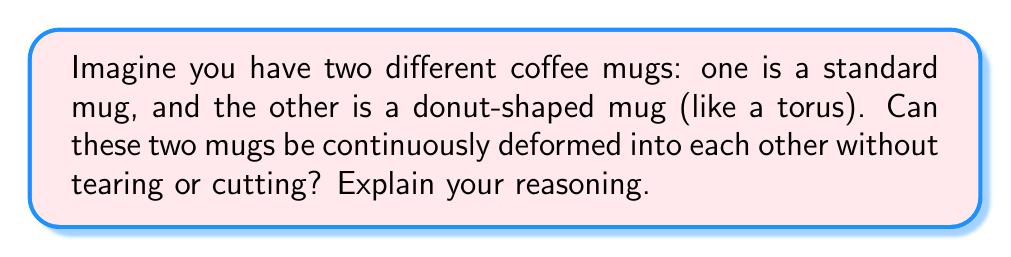Give your solution to this math problem. To answer this question, we need to understand the concept of topological equivalence. Two shapes are topologically equivalent if they can be continuously deformed into each other without tearing, cutting, or gluing.

Let's analyze the two shapes:

1. Standard mug: A standard mug is topologically equivalent to a solid cylinder. It has one hole (the handle).

2. Donut-shaped mug (torus): This mug is shaped like a donut, with one large hole through the center and another hole for the handle.

To determine if these shapes are topologically equivalent, we need to count the number of holes in each shape:

- Standard mug: 1 hole (the handle)
- Donut-shaped mug: 2 holes (the center hole and the handle)

In topology, the number of holes in a shape is called its genus. The genus is an important topological invariant, meaning it doesn't change under continuous deformations.

Since the standard mug has a genus of 1 and the donut-shaped mug has a genus of 2, they are not topologically equivalent. We cannot continuously deform one into the other without tearing or cutting.

To visualize this, imagine trying to create the center hole of the donut-shaped mug from the standard mug. You would need to puncture the body of the standard mug, which is not allowed in continuous deformation.

[asy]
import geometry;

// Standard mug
path p1 = (0,0)--(0,2)--(1,2)--(1,0)--cycle;
path p2 = (1,1.5)..(1.5,1.5)..(1.5,0.5)..(1,0.5)..cycle;
fill(p1,lightgray);
fill(p2,lightgray);
draw(p1);
draw(p2);

// Donut-shaped mug
path q1 = ellipse((5,1),1.5,1);
path q2 = ellipse((5,1),0.5,0.3);
path q3 = (6.5,1.5)..(7,1.5)..(7,0.5)..(6.5,0.5)..cycle;
fill(q1,lightgray);
unfill(q2);
fill(q3,lightgray);
draw(q1);
draw(q2);
draw(q3);

label("Standard mug", (0.5,-0.5));
label("Donut-shaped mug", (5,-0.5));
[/asy]
Answer: No, the standard mug and the donut-shaped mug cannot be continuously deformed into each other without tearing or cutting. They have different genera (1 and 2, respectively), making them topologically distinct. 